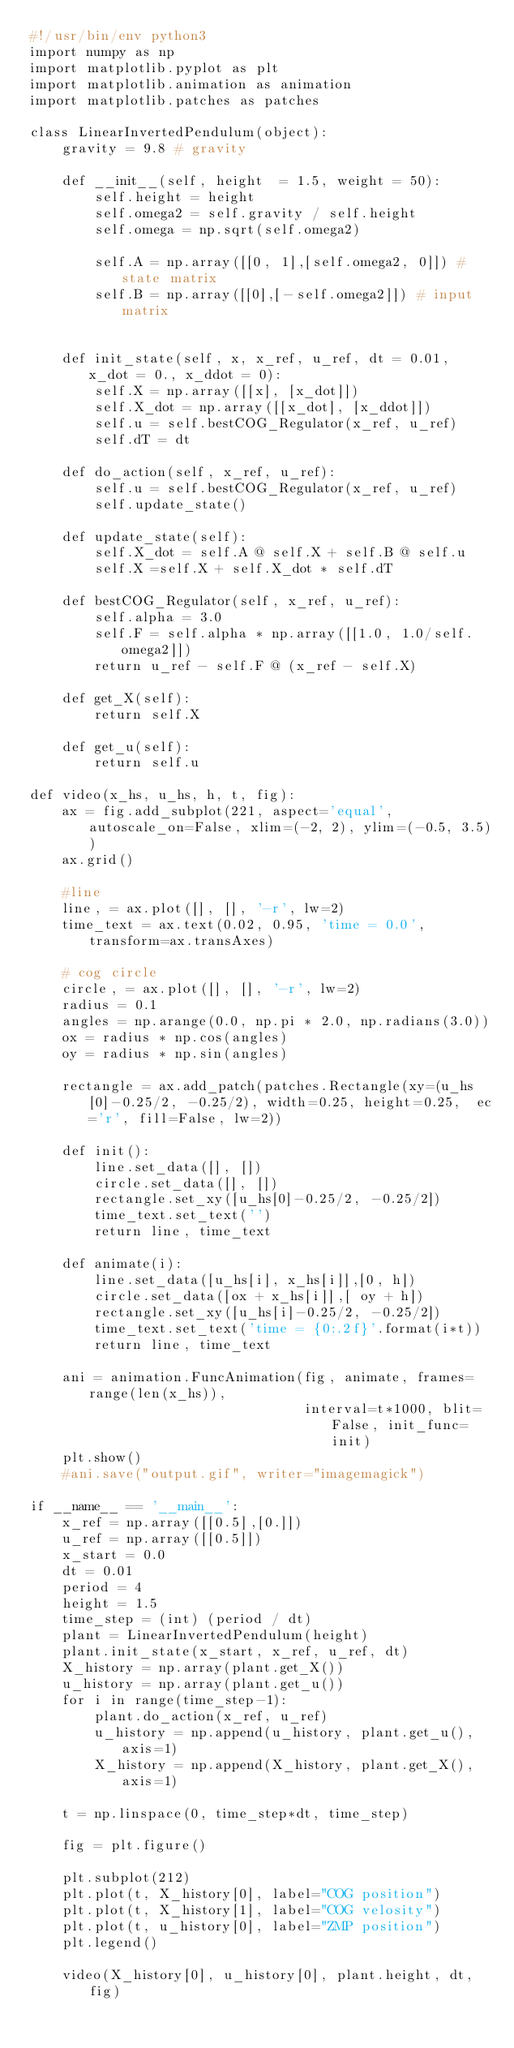<code> <loc_0><loc_0><loc_500><loc_500><_Python_>#!/usr/bin/env python3
import numpy as np
import matplotlib.pyplot as plt
import matplotlib.animation as animation
import matplotlib.patches as patches

class LinearInvertedPendulum(object):
    gravity = 9.8 # gravity

    def __init__(self, height  = 1.5, weight = 50):
        self.height = height
        self.omega2 = self.gravity / self.height
        self.omega = np.sqrt(self.omega2)

        self.A = np.array([[0, 1],[self.omega2, 0]]) # state matrix
        self.B = np.array([[0],[-self.omega2]]) # input matrix

    
    def init_state(self, x, x_ref, u_ref, dt = 0.01, x_dot = 0., x_ddot = 0):
        self.X = np.array([[x], [x_dot]])
        self.X_dot = np.array([[x_dot], [x_ddot]])
        self.u = self.bestCOG_Regulator(x_ref, u_ref)
        self.dT = dt

    def do_action(self, x_ref, u_ref):
        self.u = self.bestCOG_Regulator(x_ref, u_ref)
        self.update_state()

    def update_state(self):
        self.X_dot = self.A @ self.X + self.B @ self.u
        self.X =self.X + self.X_dot * self.dT 

    def bestCOG_Regulator(self, x_ref, u_ref):
        self.alpha = 3.0
        self.F = self.alpha * np.array([[1.0, 1.0/self.omega2]])
        return u_ref - self.F @ (x_ref - self.X)

    def get_X(self):
        return self.X
    
    def get_u(self):
        return self.u

def video(x_hs, u_hs, h, t, fig):
    ax = fig.add_subplot(221, aspect='equal', autoscale_on=False, xlim=(-2, 2), ylim=(-0.5, 3.5))
    ax.grid()

    #line
    line, = ax.plot([], [], '-r', lw=2)
    time_text = ax.text(0.02, 0.95, 'time = 0.0', transform=ax.transAxes)

    # cog circle
    circle, = ax.plot([], [], '-r', lw=2)
    radius = 0.1
    angles = np.arange(0.0, np.pi * 2.0, np.radians(3.0))
    ox = radius * np.cos(angles) 
    oy = radius * np.sin(angles)

    rectangle = ax.add_patch(patches.Rectangle(xy=(u_hs[0]-0.25/2, -0.25/2), width=0.25, height=0.25,  ec='r', fill=False, lw=2))

    def init():
        line.set_data([], [])
        circle.set_data([], [])
        rectangle.set_xy([u_hs[0]-0.25/2, -0.25/2])
        time_text.set_text('')
        return line, time_text

    def animate(i):
        line.set_data([u_hs[i], x_hs[i]],[0, h])
        circle.set_data([ox + x_hs[i]],[ oy + h])
        rectangle.set_xy([u_hs[i]-0.25/2, -0.25/2])
        time_text.set_text('time = {0:.2f}'.format(i*t))
        return line, time_text

    ani = animation.FuncAnimation(fig, animate, frames=range(len(x_hs)),
                                  interval=t*1000, blit=False, init_func=init)
    plt.show()
    #ani.save("output.gif", writer="imagemagick")

if __name__ == '__main__':
    x_ref = np.array([[0.5],[0.]])
    u_ref = np.array([[0.5]])
    x_start = 0.0
    dt = 0.01
    period = 4
    height = 1.5
    time_step = (int) (period / dt)
    plant = LinearInvertedPendulum(height)
    plant.init_state(x_start, x_ref, u_ref, dt)
    X_history = np.array(plant.get_X())
    u_history = np.array(plant.get_u())
    for i in range(time_step-1):
        plant.do_action(x_ref, u_ref)
        u_history = np.append(u_history, plant.get_u(), axis=1)
        X_history = np.append(X_history, plant.get_X(), axis=1)

    t = np.linspace(0, time_step*dt, time_step)

    fig = plt.figure()

    plt.subplot(212)
    plt.plot(t, X_history[0], label="COG position")
    plt.plot(t, X_history[1], label="COG velosity")
    plt.plot(t, u_history[0], label="ZMP position")
    plt.legend()
    
    video(X_history[0], u_history[0], plant.height, dt, fig)
</code> 